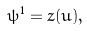Convert formula to latex. <formula><loc_0><loc_0><loc_500><loc_500>\psi ^ { 1 } = z ( u ) ,</formula> 